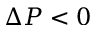<formula> <loc_0><loc_0><loc_500><loc_500>\Delta P < 0</formula> 